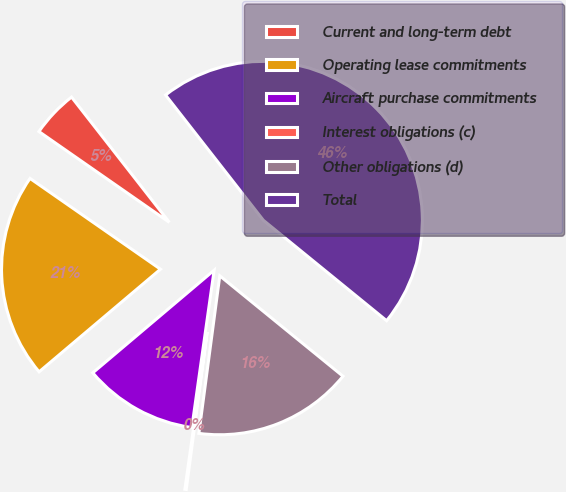<chart> <loc_0><loc_0><loc_500><loc_500><pie_chart><fcel>Current and long-term debt<fcel>Operating lease commitments<fcel>Aircraft purchase commitments<fcel>Interest obligations (c)<fcel>Other obligations (d)<fcel>Total<nl><fcel>4.77%<fcel>20.85%<fcel>11.59%<fcel>0.14%<fcel>16.22%<fcel>46.44%<nl></chart> 